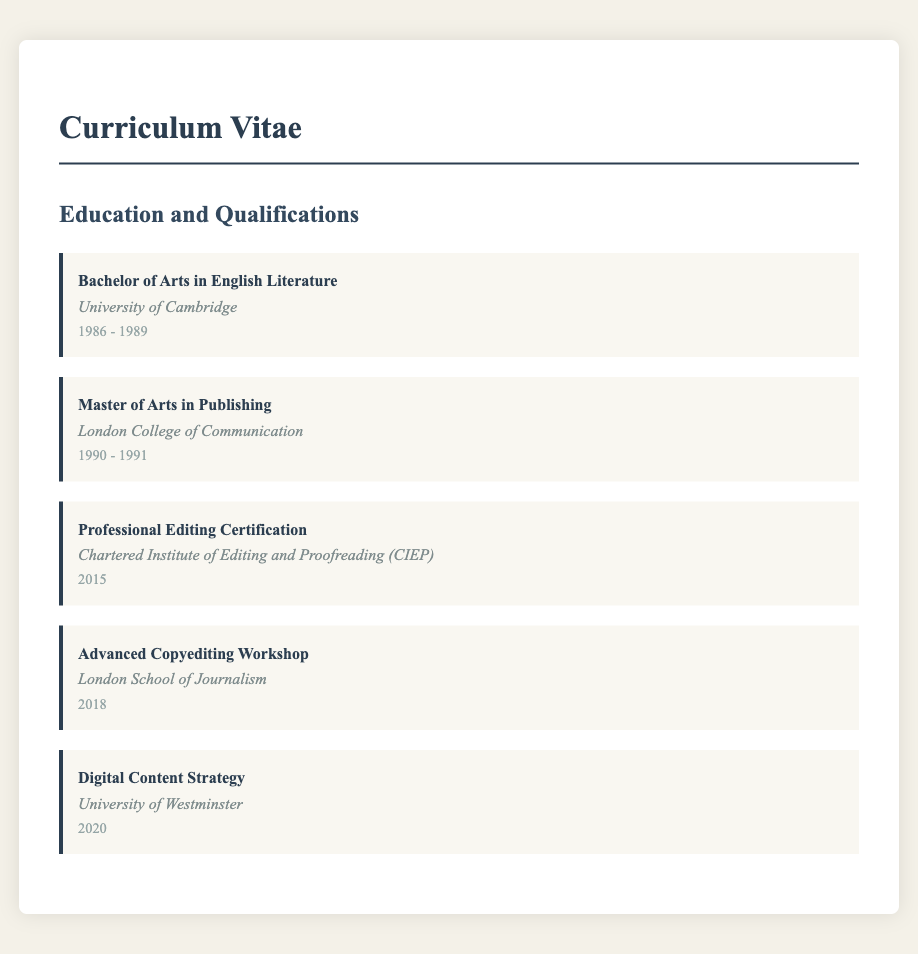What is the highest degree obtained? The highest degree in the document is the Master's degree, specifically in Publishing.
Answer: Master of Arts in Publishing Which institution awarded the Bachelor's degree? The document states that the Bachelor's degree in English Literature was awarded by the University of Cambridge.
Answer: University of Cambridge In what year was the Professional Editing Certification completed? The completion year for the Professional Editing Certification is explicitly mentioned as 2015.
Answer: 2015 What training was taken in 2020? The document specifies that the training in 2020 was related to Digital Content Strategy.
Answer: Digital Content Strategy How many years did the Bachelor's degree take? The dates for the Bachelor's degree span from 1986 to 1989, indicating it took 3 years.
Answer: 3 years What type of workshop was completed in 2018? The document indicates that the training in 2018 was an Advanced Copyediting Workshop.
Answer: Advanced Copyediting Workshop Which certification body is associated with the Professional Editing Certification? The document mentions that the Professional Editing Certification is from the Chartered Institute of Editing and Proofreading.
Answer: Chartered Institute of Editing and Proofreading What is the duration of the Master of Arts degree in Publishing? The Master of Arts in Publishing was obtained over the duration from 1990 to 1991, which is 1 year.
Answer: 1 year How many different educational qualifications are listed? There are 5 different educational qualifications listed in the document's Education and Qualifications section.
Answer: 5 